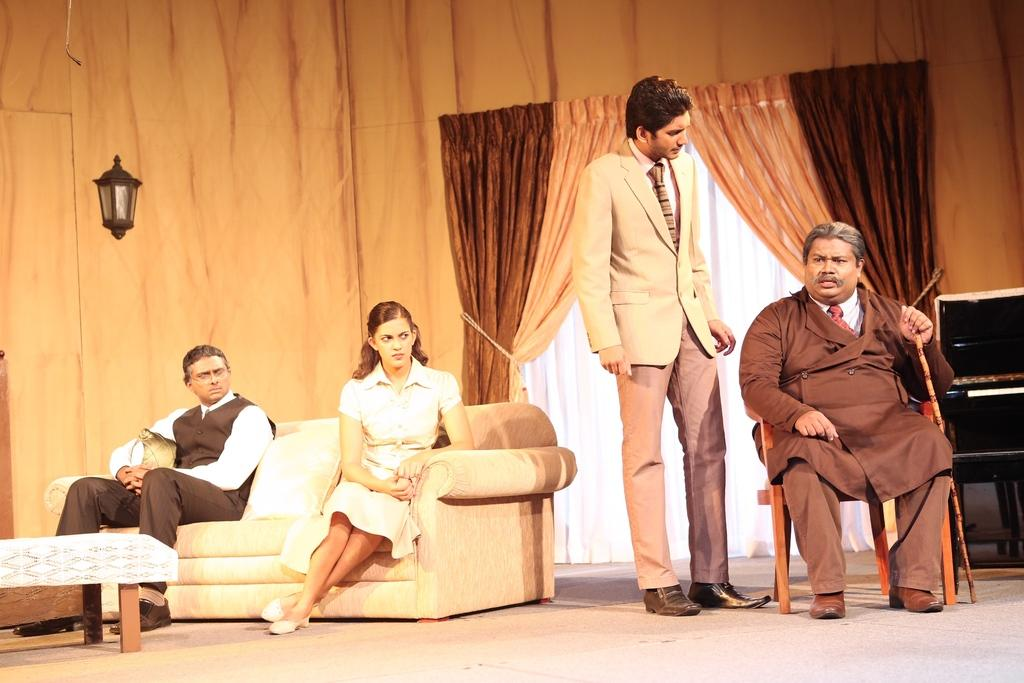What is the main subject of the image? The image depicts a platform. How many people are in the image? There are four persons in the image. What are the four persons doing in the image? The four persons are performing a role play. What can be seen in the background of the image? There is a curtain in the background of the image. What type of bread is being used as a prop in the role play? There is no bread present in the image; the four persons are performing a role play without any visible props. 